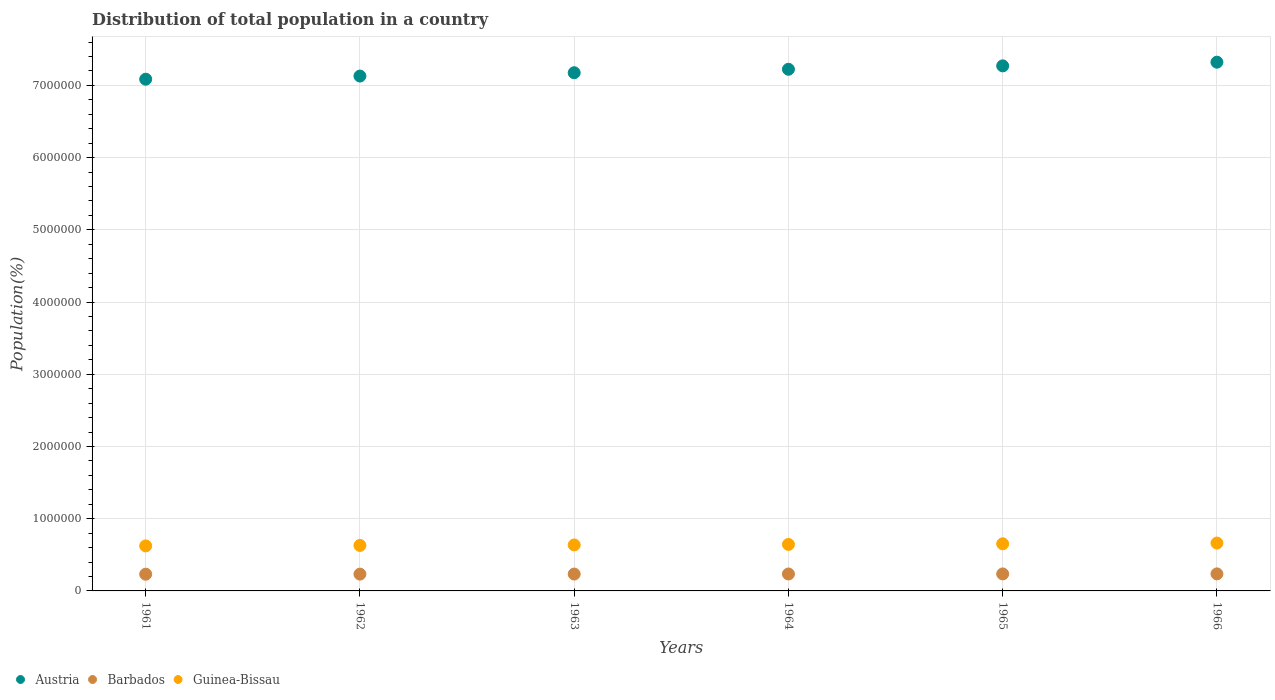How many different coloured dotlines are there?
Give a very brief answer. 3. What is the population of in Austria in 1966?
Provide a short and direct response. 7.32e+06. Across all years, what is the maximum population of in Barbados?
Offer a very short reply. 2.36e+05. Across all years, what is the minimum population of in Barbados?
Give a very brief answer. 2.32e+05. In which year was the population of in Austria maximum?
Offer a terse response. 1966. What is the total population of in Barbados in the graph?
Your answer should be very brief. 1.40e+06. What is the difference between the population of in Austria in 1964 and that in 1966?
Your answer should be very brief. -9.83e+04. What is the difference between the population of in Austria in 1966 and the population of in Guinea-Bissau in 1962?
Offer a terse response. 6.69e+06. What is the average population of in Barbados per year?
Keep it short and to the point. 2.34e+05. In the year 1965, what is the difference between the population of in Austria and population of in Barbados?
Give a very brief answer. 7.04e+06. What is the ratio of the population of in Guinea-Bissau in 1964 to that in 1965?
Your answer should be very brief. 0.99. Is the population of in Barbados in 1965 less than that in 1966?
Your answer should be compact. Yes. Is the difference between the population of in Austria in 1965 and 1966 greater than the difference between the population of in Barbados in 1965 and 1966?
Provide a short and direct response. No. What is the difference between the highest and the second highest population of in Barbados?
Keep it short and to the point. 670. What is the difference between the highest and the lowest population of in Guinea-Bissau?
Offer a very short reply. 3.92e+04. In how many years, is the population of in Barbados greater than the average population of in Barbados taken over all years?
Keep it short and to the point. 3. Does the population of in Austria monotonically increase over the years?
Your answer should be very brief. Yes. How many dotlines are there?
Your response must be concise. 3. How many years are there in the graph?
Ensure brevity in your answer.  6. Are the values on the major ticks of Y-axis written in scientific E-notation?
Offer a terse response. No. Does the graph contain grids?
Provide a short and direct response. Yes. What is the title of the graph?
Provide a short and direct response. Distribution of total population in a country. What is the label or title of the X-axis?
Provide a short and direct response. Years. What is the label or title of the Y-axis?
Give a very brief answer. Population(%). What is the Population(%) of Austria in 1961?
Your answer should be very brief. 7.09e+06. What is the Population(%) of Barbados in 1961?
Keep it short and to the point. 2.32e+05. What is the Population(%) in Guinea-Bissau in 1961?
Ensure brevity in your answer.  6.23e+05. What is the Population(%) in Austria in 1962?
Your answer should be very brief. 7.13e+06. What is the Population(%) in Barbados in 1962?
Keep it short and to the point. 2.33e+05. What is the Population(%) of Guinea-Bissau in 1962?
Give a very brief answer. 6.30e+05. What is the Population(%) of Austria in 1963?
Ensure brevity in your answer.  7.18e+06. What is the Population(%) of Barbados in 1963?
Give a very brief answer. 2.34e+05. What is the Population(%) of Guinea-Bissau in 1963?
Offer a very short reply. 6.37e+05. What is the Population(%) of Austria in 1964?
Offer a terse response. 7.22e+06. What is the Population(%) in Barbados in 1964?
Keep it short and to the point. 2.35e+05. What is the Population(%) in Guinea-Bissau in 1964?
Offer a terse response. 6.44e+05. What is the Population(%) of Austria in 1965?
Your answer should be very brief. 7.27e+06. What is the Population(%) in Barbados in 1965?
Ensure brevity in your answer.  2.35e+05. What is the Population(%) of Guinea-Bissau in 1965?
Your response must be concise. 6.53e+05. What is the Population(%) of Austria in 1966?
Offer a terse response. 7.32e+06. What is the Population(%) of Barbados in 1966?
Your answer should be compact. 2.36e+05. What is the Population(%) in Guinea-Bissau in 1966?
Offer a very short reply. 6.63e+05. Across all years, what is the maximum Population(%) in Austria?
Offer a very short reply. 7.32e+06. Across all years, what is the maximum Population(%) of Barbados?
Your answer should be compact. 2.36e+05. Across all years, what is the maximum Population(%) in Guinea-Bissau?
Your response must be concise. 6.63e+05. Across all years, what is the minimum Population(%) of Austria?
Provide a short and direct response. 7.09e+06. Across all years, what is the minimum Population(%) of Barbados?
Provide a succinct answer. 2.32e+05. Across all years, what is the minimum Population(%) of Guinea-Bissau?
Keep it short and to the point. 6.23e+05. What is the total Population(%) of Austria in the graph?
Your answer should be very brief. 4.32e+07. What is the total Population(%) in Barbados in the graph?
Provide a succinct answer. 1.40e+06. What is the total Population(%) in Guinea-Bissau in the graph?
Provide a succinct answer. 3.85e+06. What is the difference between the Population(%) in Austria in 1961 and that in 1962?
Your response must be concise. -4.36e+04. What is the difference between the Population(%) in Barbados in 1961 and that in 1962?
Your answer should be compact. -910. What is the difference between the Population(%) in Guinea-Bissau in 1961 and that in 1962?
Keep it short and to the point. -6560. What is the difference between the Population(%) in Austria in 1961 and that in 1963?
Offer a very short reply. -8.95e+04. What is the difference between the Population(%) in Barbados in 1961 and that in 1963?
Keep it short and to the point. -1913. What is the difference between the Population(%) of Guinea-Bissau in 1961 and that in 1963?
Your answer should be compact. -1.32e+04. What is the difference between the Population(%) in Austria in 1961 and that in 1964?
Ensure brevity in your answer.  -1.38e+05. What is the difference between the Population(%) in Barbados in 1961 and that in 1964?
Your response must be concise. -2873. What is the difference between the Population(%) in Guinea-Bissau in 1961 and that in 1964?
Offer a very short reply. -2.05e+04. What is the difference between the Population(%) in Austria in 1961 and that in 1965?
Ensure brevity in your answer.  -1.85e+05. What is the difference between the Population(%) of Barbados in 1961 and that in 1965?
Keep it short and to the point. -3699. What is the difference between the Population(%) of Guinea-Bissau in 1961 and that in 1965?
Provide a succinct answer. -2.92e+04. What is the difference between the Population(%) in Austria in 1961 and that in 1966?
Give a very brief answer. -2.36e+05. What is the difference between the Population(%) of Barbados in 1961 and that in 1966?
Provide a succinct answer. -4369. What is the difference between the Population(%) of Guinea-Bissau in 1961 and that in 1966?
Ensure brevity in your answer.  -3.92e+04. What is the difference between the Population(%) in Austria in 1962 and that in 1963?
Ensure brevity in your answer.  -4.59e+04. What is the difference between the Population(%) in Barbados in 1962 and that in 1963?
Ensure brevity in your answer.  -1003. What is the difference between the Population(%) in Guinea-Bissau in 1962 and that in 1963?
Provide a short and direct response. -6620. What is the difference between the Population(%) of Austria in 1962 and that in 1964?
Offer a very short reply. -9.39e+04. What is the difference between the Population(%) of Barbados in 1962 and that in 1964?
Provide a short and direct response. -1963. What is the difference between the Population(%) of Guinea-Bissau in 1962 and that in 1964?
Offer a terse response. -1.40e+04. What is the difference between the Population(%) of Austria in 1962 and that in 1965?
Your answer should be compact. -1.41e+05. What is the difference between the Population(%) of Barbados in 1962 and that in 1965?
Your response must be concise. -2789. What is the difference between the Population(%) of Guinea-Bissau in 1962 and that in 1965?
Your answer should be compact. -2.26e+04. What is the difference between the Population(%) of Austria in 1962 and that in 1966?
Ensure brevity in your answer.  -1.92e+05. What is the difference between the Population(%) in Barbados in 1962 and that in 1966?
Make the answer very short. -3459. What is the difference between the Population(%) of Guinea-Bissau in 1962 and that in 1966?
Provide a succinct answer. -3.26e+04. What is the difference between the Population(%) of Austria in 1963 and that in 1964?
Your response must be concise. -4.80e+04. What is the difference between the Population(%) in Barbados in 1963 and that in 1964?
Provide a short and direct response. -960. What is the difference between the Population(%) in Guinea-Bissau in 1963 and that in 1964?
Give a very brief answer. -7369. What is the difference between the Population(%) in Austria in 1963 and that in 1965?
Your answer should be compact. -9.51e+04. What is the difference between the Population(%) in Barbados in 1963 and that in 1965?
Your response must be concise. -1786. What is the difference between the Population(%) of Guinea-Bissau in 1963 and that in 1965?
Offer a very short reply. -1.60e+04. What is the difference between the Population(%) in Austria in 1963 and that in 1966?
Make the answer very short. -1.46e+05. What is the difference between the Population(%) in Barbados in 1963 and that in 1966?
Offer a very short reply. -2456. What is the difference between the Population(%) of Guinea-Bissau in 1963 and that in 1966?
Offer a very short reply. -2.60e+04. What is the difference between the Population(%) of Austria in 1964 and that in 1965?
Keep it short and to the point. -4.71e+04. What is the difference between the Population(%) of Barbados in 1964 and that in 1965?
Give a very brief answer. -826. What is the difference between the Population(%) of Guinea-Bissau in 1964 and that in 1965?
Offer a very short reply. -8604. What is the difference between the Population(%) of Austria in 1964 and that in 1966?
Provide a succinct answer. -9.83e+04. What is the difference between the Population(%) in Barbados in 1964 and that in 1966?
Your response must be concise. -1496. What is the difference between the Population(%) of Guinea-Bissau in 1964 and that in 1966?
Your response must be concise. -1.86e+04. What is the difference between the Population(%) of Austria in 1965 and that in 1966?
Ensure brevity in your answer.  -5.12e+04. What is the difference between the Population(%) in Barbados in 1965 and that in 1966?
Your answer should be compact. -670. What is the difference between the Population(%) in Guinea-Bissau in 1965 and that in 1966?
Ensure brevity in your answer.  -1.00e+04. What is the difference between the Population(%) of Austria in 1961 and the Population(%) of Barbados in 1962?
Your answer should be compact. 6.85e+06. What is the difference between the Population(%) of Austria in 1961 and the Population(%) of Guinea-Bissau in 1962?
Provide a succinct answer. 6.46e+06. What is the difference between the Population(%) of Barbados in 1961 and the Population(%) of Guinea-Bissau in 1962?
Provide a short and direct response. -3.98e+05. What is the difference between the Population(%) of Austria in 1961 and the Population(%) of Barbados in 1963?
Your response must be concise. 6.85e+06. What is the difference between the Population(%) in Austria in 1961 and the Population(%) in Guinea-Bissau in 1963?
Offer a very short reply. 6.45e+06. What is the difference between the Population(%) of Barbados in 1961 and the Population(%) of Guinea-Bissau in 1963?
Keep it short and to the point. -4.05e+05. What is the difference between the Population(%) in Austria in 1961 and the Population(%) in Barbados in 1964?
Your answer should be compact. 6.85e+06. What is the difference between the Population(%) in Austria in 1961 and the Population(%) in Guinea-Bissau in 1964?
Your answer should be very brief. 6.44e+06. What is the difference between the Population(%) of Barbados in 1961 and the Population(%) of Guinea-Bissau in 1964?
Keep it short and to the point. -4.12e+05. What is the difference between the Population(%) of Austria in 1961 and the Population(%) of Barbados in 1965?
Offer a terse response. 6.85e+06. What is the difference between the Population(%) of Austria in 1961 and the Population(%) of Guinea-Bissau in 1965?
Offer a very short reply. 6.43e+06. What is the difference between the Population(%) in Barbados in 1961 and the Population(%) in Guinea-Bissau in 1965?
Offer a terse response. -4.21e+05. What is the difference between the Population(%) of Austria in 1961 and the Population(%) of Barbados in 1966?
Ensure brevity in your answer.  6.85e+06. What is the difference between the Population(%) of Austria in 1961 and the Population(%) of Guinea-Bissau in 1966?
Ensure brevity in your answer.  6.42e+06. What is the difference between the Population(%) of Barbados in 1961 and the Population(%) of Guinea-Bissau in 1966?
Your response must be concise. -4.31e+05. What is the difference between the Population(%) in Austria in 1962 and the Population(%) in Barbados in 1963?
Your response must be concise. 6.90e+06. What is the difference between the Population(%) of Austria in 1962 and the Population(%) of Guinea-Bissau in 1963?
Offer a terse response. 6.49e+06. What is the difference between the Population(%) in Barbados in 1962 and the Population(%) in Guinea-Bissau in 1963?
Keep it short and to the point. -4.04e+05. What is the difference between the Population(%) in Austria in 1962 and the Population(%) in Barbados in 1964?
Keep it short and to the point. 6.90e+06. What is the difference between the Population(%) of Austria in 1962 and the Population(%) of Guinea-Bissau in 1964?
Offer a terse response. 6.49e+06. What is the difference between the Population(%) of Barbados in 1962 and the Population(%) of Guinea-Bissau in 1964?
Offer a terse response. -4.11e+05. What is the difference between the Population(%) in Austria in 1962 and the Population(%) in Barbados in 1965?
Provide a succinct answer. 6.89e+06. What is the difference between the Population(%) of Austria in 1962 and the Population(%) of Guinea-Bissau in 1965?
Make the answer very short. 6.48e+06. What is the difference between the Population(%) of Barbados in 1962 and the Population(%) of Guinea-Bissau in 1965?
Provide a short and direct response. -4.20e+05. What is the difference between the Population(%) in Austria in 1962 and the Population(%) in Barbados in 1966?
Provide a short and direct response. 6.89e+06. What is the difference between the Population(%) of Austria in 1962 and the Population(%) of Guinea-Bissau in 1966?
Make the answer very short. 6.47e+06. What is the difference between the Population(%) of Barbados in 1962 and the Population(%) of Guinea-Bissau in 1966?
Provide a succinct answer. -4.30e+05. What is the difference between the Population(%) of Austria in 1963 and the Population(%) of Barbados in 1964?
Keep it short and to the point. 6.94e+06. What is the difference between the Population(%) of Austria in 1963 and the Population(%) of Guinea-Bissau in 1964?
Ensure brevity in your answer.  6.53e+06. What is the difference between the Population(%) of Barbados in 1963 and the Population(%) of Guinea-Bissau in 1964?
Ensure brevity in your answer.  -4.10e+05. What is the difference between the Population(%) in Austria in 1963 and the Population(%) in Barbados in 1965?
Ensure brevity in your answer.  6.94e+06. What is the difference between the Population(%) in Austria in 1963 and the Population(%) in Guinea-Bissau in 1965?
Make the answer very short. 6.52e+06. What is the difference between the Population(%) in Barbados in 1963 and the Population(%) in Guinea-Bissau in 1965?
Your answer should be compact. -4.19e+05. What is the difference between the Population(%) in Austria in 1963 and the Population(%) in Barbados in 1966?
Keep it short and to the point. 6.94e+06. What is the difference between the Population(%) in Austria in 1963 and the Population(%) in Guinea-Bissau in 1966?
Your answer should be compact. 6.51e+06. What is the difference between the Population(%) in Barbados in 1963 and the Population(%) in Guinea-Bissau in 1966?
Ensure brevity in your answer.  -4.29e+05. What is the difference between the Population(%) in Austria in 1964 and the Population(%) in Barbados in 1965?
Offer a terse response. 6.99e+06. What is the difference between the Population(%) of Austria in 1964 and the Population(%) of Guinea-Bissau in 1965?
Give a very brief answer. 6.57e+06. What is the difference between the Population(%) of Barbados in 1964 and the Population(%) of Guinea-Bissau in 1965?
Make the answer very short. -4.18e+05. What is the difference between the Population(%) in Austria in 1964 and the Population(%) in Barbados in 1966?
Your answer should be very brief. 6.99e+06. What is the difference between the Population(%) of Austria in 1964 and the Population(%) of Guinea-Bissau in 1966?
Give a very brief answer. 6.56e+06. What is the difference between the Population(%) in Barbados in 1964 and the Population(%) in Guinea-Bissau in 1966?
Your answer should be very brief. -4.28e+05. What is the difference between the Population(%) of Austria in 1965 and the Population(%) of Barbados in 1966?
Make the answer very short. 7.03e+06. What is the difference between the Population(%) of Austria in 1965 and the Population(%) of Guinea-Bissau in 1966?
Make the answer very short. 6.61e+06. What is the difference between the Population(%) of Barbados in 1965 and the Population(%) of Guinea-Bissau in 1966?
Your answer should be very brief. -4.27e+05. What is the average Population(%) in Austria per year?
Keep it short and to the point. 7.20e+06. What is the average Population(%) of Barbados per year?
Give a very brief answer. 2.34e+05. What is the average Population(%) in Guinea-Bissau per year?
Make the answer very short. 6.42e+05. In the year 1961, what is the difference between the Population(%) in Austria and Population(%) in Barbados?
Make the answer very short. 6.85e+06. In the year 1961, what is the difference between the Population(%) of Austria and Population(%) of Guinea-Bissau?
Provide a succinct answer. 6.46e+06. In the year 1961, what is the difference between the Population(%) of Barbados and Population(%) of Guinea-Bissau?
Ensure brevity in your answer.  -3.92e+05. In the year 1962, what is the difference between the Population(%) of Austria and Population(%) of Barbados?
Your answer should be very brief. 6.90e+06. In the year 1962, what is the difference between the Population(%) in Austria and Population(%) in Guinea-Bissau?
Ensure brevity in your answer.  6.50e+06. In the year 1962, what is the difference between the Population(%) in Barbados and Population(%) in Guinea-Bissau?
Provide a succinct answer. -3.97e+05. In the year 1963, what is the difference between the Population(%) in Austria and Population(%) in Barbados?
Provide a succinct answer. 6.94e+06. In the year 1963, what is the difference between the Population(%) in Austria and Population(%) in Guinea-Bissau?
Ensure brevity in your answer.  6.54e+06. In the year 1963, what is the difference between the Population(%) of Barbados and Population(%) of Guinea-Bissau?
Your answer should be compact. -4.03e+05. In the year 1964, what is the difference between the Population(%) of Austria and Population(%) of Barbados?
Your answer should be very brief. 6.99e+06. In the year 1964, what is the difference between the Population(%) in Austria and Population(%) in Guinea-Bissau?
Offer a terse response. 6.58e+06. In the year 1964, what is the difference between the Population(%) of Barbados and Population(%) of Guinea-Bissau?
Offer a very short reply. -4.09e+05. In the year 1965, what is the difference between the Population(%) in Austria and Population(%) in Barbados?
Ensure brevity in your answer.  7.04e+06. In the year 1965, what is the difference between the Population(%) of Austria and Population(%) of Guinea-Bissau?
Keep it short and to the point. 6.62e+06. In the year 1965, what is the difference between the Population(%) in Barbados and Population(%) in Guinea-Bissau?
Offer a very short reply. -4.17e+05. In the year 1966, what is the difference between the Population(%) in Austria and Population(%) in Barbados?
Keep it short and to the point. 7.09e+06. In the year 1966, what is the difference between the Population(%) of Austria and Population(%) of Guinea-Bissau?
Ensure brevity in your answer.  6.66e+06. In the year 1966, what is the difference between the Population(%) of Barbados and Population(%) of Guinea-Bissau?
Make the answer very short. -4.27e+05. What is the ratio of the Population(%) in Austria in 1961 to that in 1963?
Offer a terse response. 0.99. What is the ratio of the Population(%) of Guinea-Bissau in 1961 to that in 1963?
Keep it short and to the point. 0.98. What is the ratio of the Population(%) in Barbados in 1961 to that in 1964?
Keep it short and to the point. 0.99. What is the ratio of the Population(%) in Guinea-Bissau in 1961 to that in 1964?
Keep it short and to the point. 0.97. What is the ratio of the Population(%) of Austria in 1961 to that in 1965?
Your answer should be very brief. 0.97. What is the ratio of the Population(%) of Barbados in 1961 to that in 1965?
Provide a succinct answer. 0.98. What is the ratio of the Population(%) in Guinea-Bissau in 1961 to that in 1965?
Provide a short and direct response. 0.96. What is the ratio of the Population(%) in Austria in 1961 to that in 1966?
Make the answer very short. 0.97. What is the ratio of the Population(%) of Barbados in 1961 to that in 1966?
Keep it short and to the point. 0.98. What is the ratio of the Population(%) of Guinea-Bissau in 1961 to that in 1966?
Offer a very short reply. 0.94. What is the ratio of the Population(%) in Austria in 1962 to that in 1963?
Provide a succinct answer. 0.99. What is the ratio of the Population(%) of Barbados in 1962 to that in 1963?
Make the answer very short. 1. What is the ratio of the Population(%) of Barbados in 1962 to that in 1964?
Provide a succinct answer. 0.99. What is the ratio of the Population(%) of Guinea-Bissau in 1962 to that in 1964?
Your answer should be compact. 0.98. What is the ratio of the Population(%) of Austria in 1962 to that in 1965?
Your answer should be very brief. 0.98. What is the ratio of the Population(%) in Guinea-Bissau in 1962 to that in 1965?
Provide a short and direct response. 0.97. What is the ratio of the Population(%) of Austria in 1962 to that in 1966?
Offer a very short reply. 0.97. What is the ratio of the Population(%) of Barbados in 1962 to that in 1966?
Offer a very short reply. 0.99. What is the ratio of the Population(%) of Guinea-Bissau in 1962 to that in 1966?
Your answer should be compact. 0.95. What is the ratio of the Population(%) in Austria in 1963 to that in 1964?
Make the answer very short. 0.99. What is the ratio of the Population(%) of Austria in 1963 to that in 1965?
Your answer should be very brief. 0.99. What is the ratio of the Population(%) in Barbados in 1963 to that in 1965?
Give a very brief answer. 0.99. What is the ratio of the Population(%) in Guinea-Bissau in 1963 to that in 1965?
Your answer should be very brief. 0.98. What is the ratio of the Population(%) in Austria in 1963 to that in 1966?
Your answer should be compact. 0.98. What is the ratio of the Population(%) in Barbados in 1963 to that in 1966?
Make the answer very short. 0.99. What is the ratio of the Population(%) in Guinea-Bissau in 1963 to that in 1966?
Offer a terse response. 0.96. What is the ratio of the Population(%) of Austria in 1964 to that in 1965?
Your answer should be very brief. 0.99. What is the ratio of the Population(%) in Austria in 1964 to that in 1966?
Your answer should be very brief. 0.99. What is the ratio of the Population(%) in Barbados in 1964 to that in 1966?
Your response must be concise. 0.99. What is the ratio of the Population(%) of Guinea-Bissau in 1964 to that in 1966?
Offer a very short reply. 0.97. What is the ratio of the Population(%) in Austria in 1965 to that in 1966?
Your answer should be very brief. 0.99. What is the ratio of the Population(%) of Guinea-Bissau in 1965 to that in 1966?
Offer a terse response. 0.98. What is the difference between the highest and the second highest Population(%) in Austria?
Provide a short and direct response. 5.12e+04. What is the difference between the highest and the second highest Population(%) of Barbados?
Provide a succinct answer. 670. What is the difference between the highest and the second highest Population(%) of Guinea-Bissau?
Your answer should be compact. 1.00e+04. What is the difference between the highest and the lowest Population(%) in Austria?
Ensure brevity in your answer.  2.36e+05. What is the difference between the highest and the lowest Population(%) in Barbados?
Provide a succinct answer. 4369. What is the difference between the highest and the lowest Population(%) of Guinea-Bissau?
Make the answer very short. 3.92e+04. 